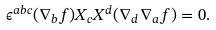<formula> <loc_0><loc_0><loc_500><loc_500>\epsilon ^ { a b c } ( \nabla _ { b } f ) X _ { c } X ^ { d } ( \nabla _ { d } \nabla _ { a } f ) = 0 .</formula> 